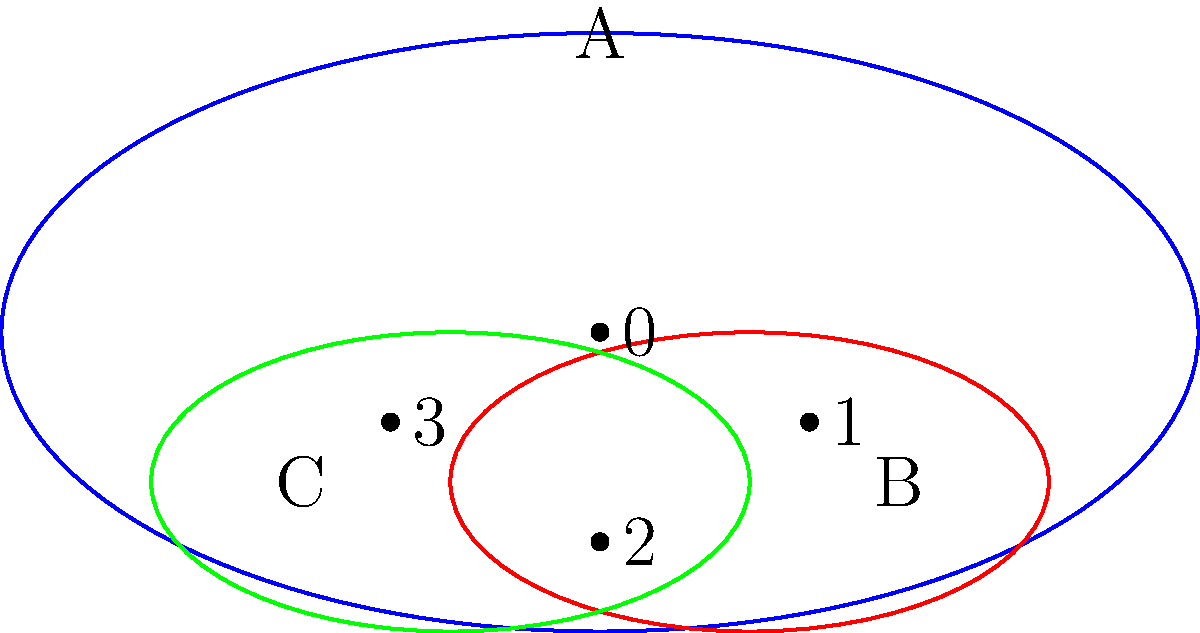In DNA sequence analysis, consider the set $A = \{0, 1, 2, 3\}$ representing the four nucleotides (Adenine, Cytosine, Guanine, Thymine). Two subsets $B = \{1, 2\}$ and $C = \{2, 3\}$ are identified as potential mutation sites. Which of the following statements is true about the subgroups generated by these sets under the operation of addition modulo 4? To determine the subgroups generated by sets B and C, we need to follow these steps:

1. First, recall that a subgroup must contain the identity element (0 in modulo 4 addition) and be closed under the group operation.

2. For set B = {1, 2}:
   - 1 + 1 ≡ 2 (mod 4)
   - 1 + 2 ≡ 3 (mod 4)
   - 2 + 2 ≡ 0 (mod 4)
   The subgroup generated by B is {0, 1, 2, 3}, which is the entire group A.

3. For set C = {2, 3}:
   - 2 + 2 ≡ 0 (mod 4)
   - 2 + 3 ≡ 1 (mod 4)
   - 3 + 3 ≡ 2 (mod 4)
   The subgroup generated by C is also {0, 1, 2, 3}, which is the entire group A.

4. The intersection of the subgroups generated by B and C is therefore A itself.

5. In group theory, when two subgroups generate the entire group, they are said to have no proper common subgroup other than the entire group itself.

Therefore, the subgroups generated by B and C are both equal to A, and their intersection is A as well.
Answer: The subgroups generated by B and C are both equal to A. 